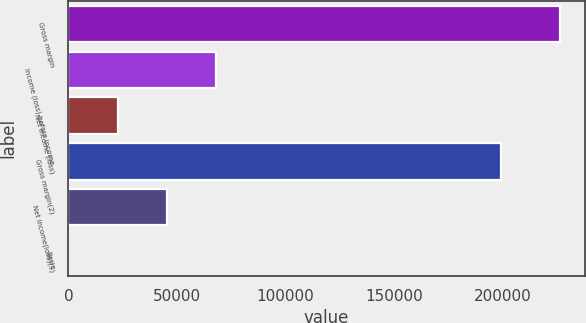Convert chart to OTSL. <chart><loc_0><loc_0><loc_500><loc_500><bar_chart><fcel>Gross margin<fcel>Income (loss) before income<fcel>Net income (loss)<fcel>Gross margin(2)<fcel>Net income(loss)(3)<fcel>Basic<nl><fcel>226572<fcel>67971.7<fcel>22657.3<fcel>199426<fcel>45314.5<fcel>0.1<nl></chart> 